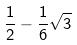<formula> <loc_0><loc_0><loc_500><loc_500>\frac { 1 } { 2 } - \frac { 1 } { 6 } \sqrt { 3 }</formula> 